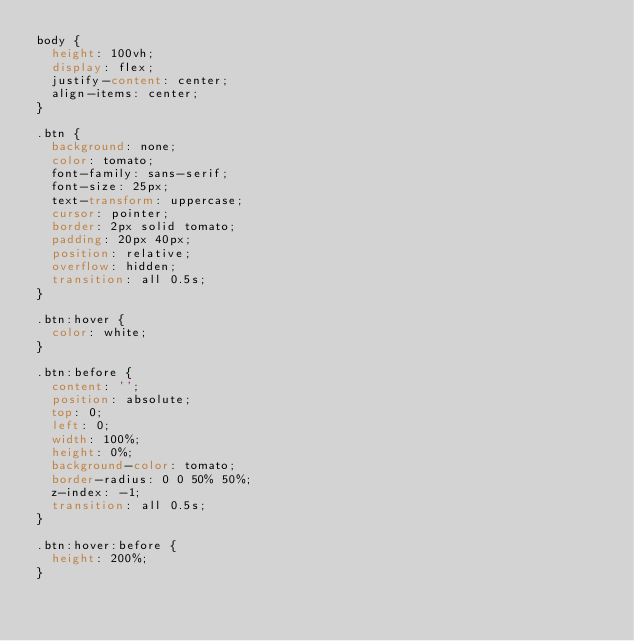Convert code to text. <code><loc_0><loc_0><loc_500><loc_500><_CSS_>body {
  height: 100vh;
  display: flex;
  justify-content: center;
  align-items: center;
}

.btn {
  background: none;
  color: tomato;
  font-family: sans-serif;
  font-size: 25px;
  text-transform: uppercase;
  cursor: pointer;
  border: 2px solid tomato;
  padding: 20px 40px;
  position: relative;
  overflow: hidden;
  transition: all 0.5s;
}

.btn:hover {
  color: white;
}

.btn:before {
  content: '';
  position: absolute;
  top: 0;
  left: 0;
  width: 100%;
  height: 0%;
  background-color: tomato;
  border-radius: 0 0 50% 50%;
  z-index: -1;
  transition: all 0.5s;
}

.btn:hover:before {
  height: 200%;
}</code> 